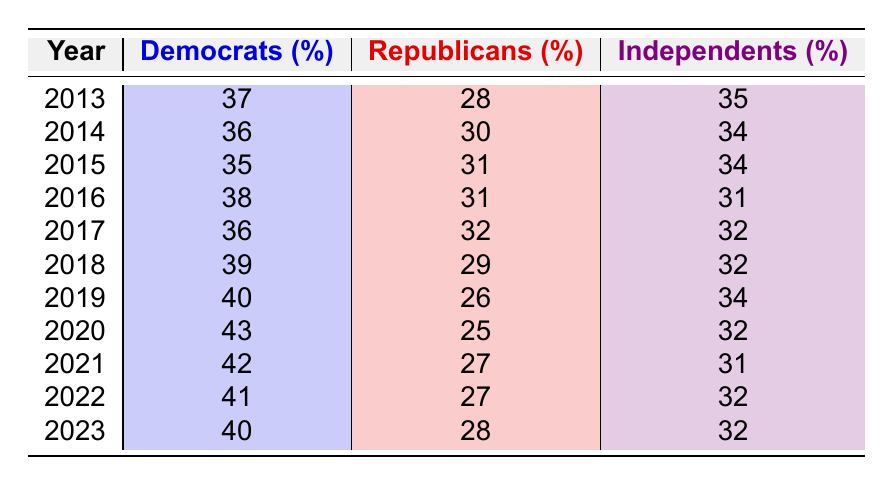What was the percentage of Republicans in 2020? Looking at the row for the year 2020, the percentage of Republicans is listed as 25%.
Answer: 25 In which year did Democrats have the highest percentage? The highest percentage for Democrats can be found by scanning each row. The highest is 43%, which occurs in 2020.
Answer: 2020 What is the average percentage of Independents over the years provided? Summing the percentages of Independents from each year: (35 + 34 + 34 + 31 + 32 + 32 + 34 + 32 + 31 + 32 + 32) = 357. There are 11 years of data, so the average is 357 / 11 = 32.5.
Answer: 32.5 Was there a year where the percentage of Republicans was lower than 25%? Checking the data, the lowest percentage for Republicans is 25% in 2020, so there is no year with a lower percentage.
Answer: No What trend can be observed in Democratic percentages from 2013 to 2023? By examining each year, it appears that Democratic percentages generally increased from 37% in 2013 to a peak of 43% in 2020, before slightly decreasing to 40% in 2023. This indicates an overall upward trend with a slight decline at the end.
Answer: Overall upward trend How much did the percentage of Independents change from 2013 to 2023? In 2013, Independents accounted for 35%, and by 2023 this figure is 32%. Thus, the change is a decrease of 3 percentage points from 35% to 32%.
Answer: Decrease of 3 percentage points In which year did Independents have the same percentage as in 2018? Looking for the percentage from 2018, which is 32%, we find this percentage appears again in 2017, 2021, 2022, and 2023.
Answer: 2017, 2021, 2022, and 2023 What was the percentage difference between Democrats and Republicans in 2019? In 2019, Democrats had 40% while Republicans had 26%. The difference is calculated as 40 - 26 = 14 percentage points.
Answer: 14 percentage points 